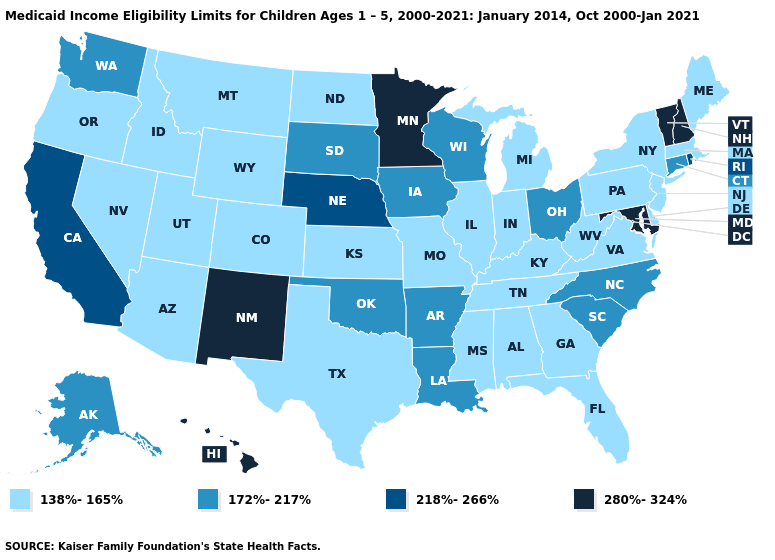What is the lowest value in states that border New Jersey?
Be succinct. 138%-165%. Name the states that have a value in the range 172%-217%?
Short answer required. Alaska, Arkansas, Connecticut, Iowa, Louisiana, North Carolina, Ohio, Oklahoma, South Carolina, South Dakota, Washington, Wisconsin. Does Pennsylvania have the highest value in the Northeast?
Be succinct. No. What is the value of Nebraska?
Answer briefly. 218%-266%. Among the states that border New Hampshire , which have the lowest value?
Write a very short answer. Maine, Massachusetts. Does Oklahoma have the same value as Iowa?
Write a very short answer. Yes. Does Oregon have the highest value in the USA?
Short answer required. No. Name the states that have a value in the range 138%-165%?
Quick response, please. Alabama, Arizona, Colorado, Delaware, Florida, Georgia, Idaho, Illinois, Indiana, Kansas, Kentucky, Maine, Massachusetts, Michigan, Mississippi, Missouri, Montana, Nevada, New Jersey, New York, North Dakota, Oregon, Pennsylvania, Tennessee, Texas, Utah, Virginia, West Virginia, Wyoming. What is the value of Arizona?
Answer briefly. 138%-165%. Does the first symbol in the legend represent the smallest category?
Write a very short answer. Yes. Name the states that have a value in the range 280%-324%?
Be succinct. Hawaii, Maryland, Minnesota, New Hampshire, New Mexico, Vermont. Which states have the highest value in the USA?
Keep it brief. Hawaii, Maryland, Minnesota, New Hampshire, New Mexico, Vermont. What is the value of Washington?
Be succinct. 172%-217%. Name the states that have a value in the range 218%-266%?
Give a very brief answer. California, Nebraska, Rhode Island. What is the value of Vermont?
Quick response, please. 280%-324%. 